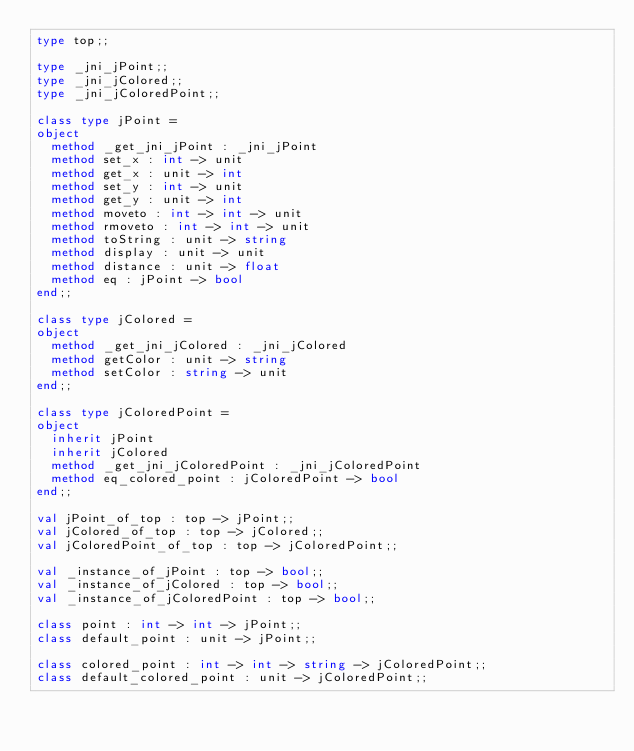<code> <loc_0><loc_0><loc_500><loc_500><_OCaml_>type top;;

type _jni_jPoint;;
type _jni_jColored;;
type _jni_jColoredPoint;;

class type jPoint =
object
  method _get_jni_jPoint : _jni_jPoint
  method set_x : int -> unit
  method get_x : unit -> int
  method set_y : int -> unit
  method get_y : unit -> int
  method moveto : int -> int -> unit
  method rmoveto : int -> int -> unit
  method toString : unit -> string
  method display : unit -> unit
  method distance : unit -> float
  method eq : jPoint -> bool
end;;

class type jColored =
object
  method _get_jni_jColored : _jni_jColored
  method getColor : unit -> string
  method setColor : string -> unit
end;;

class type jColoredPoint =
object
  inherit jPoint
  inherit jColored
  method _get_jni_jColoredPoint : _jni_jColoredPoint
  method eq_colored_point : jColoredPoint -> bool
end;;

val jPoint_of_top : top -> jPoint;; 
val jColored_of_top : top -> jColored;;
val jColoredPoint_of_top : top -> jColoredPoint;;

val _instance_of_jPoint : top -> bool;;
val _instance_of_jColored : top -> bool;;
val _instance_of_jColoredPoint : top -> bool;;

class point : int -> int -> jPoint;;
class default_point : unit -> jPoint;;

class colored_point : int -> int -> string -> jColoredPoint;;
class default_colored_point : unit -> jColoredPoint;;
</code> 